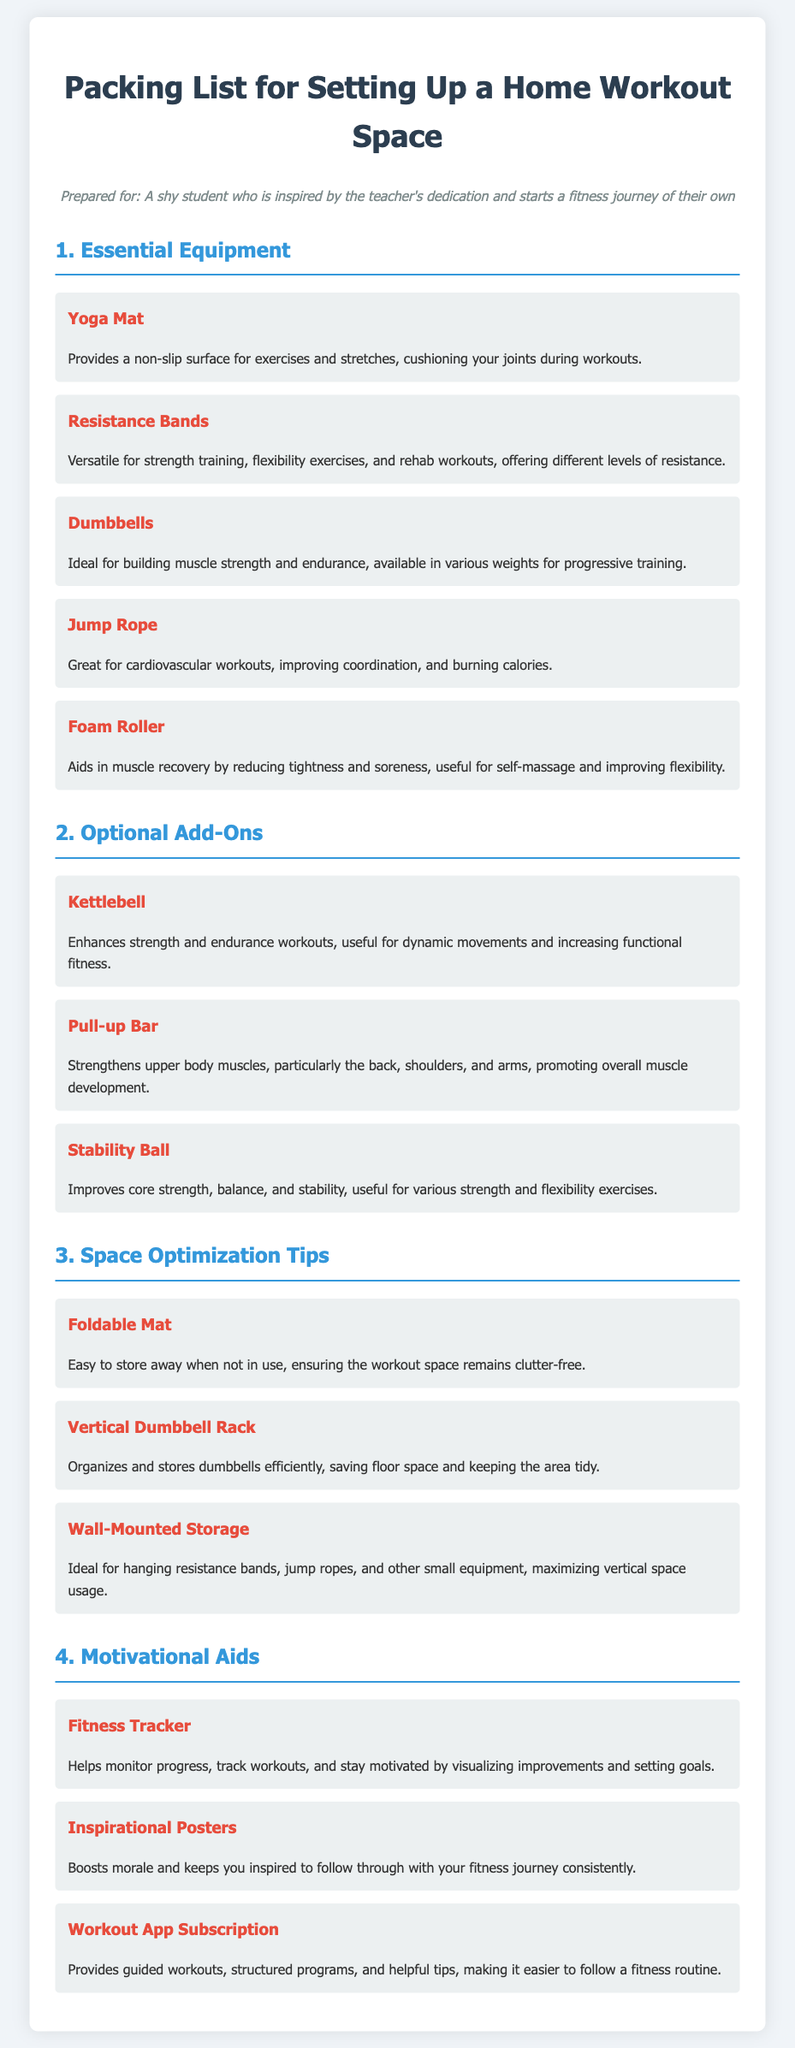what is the first piece of essential equipment listed? The first essential equipment mentioned in the list is the Yoga Mat.
Answer: Yoga Mat how many optional add-ons are mentioned? There are three optional add-ons specified in the document.
Answer: 3 what is one benefit of using resistance bands? Resistance bands are versatile for strength training, flexibility exercises, and rehab workouts.
Answer: Versatile for strength training which item aids in muscle recovery? The Foam Roller aids in muscle recovery by reducing tightness and soreness.
Answer: Foam Roller what type of storage is suggested for maximizing vertical space? Wall-Mounted Storage is recommended for hanging small equipment.
Answer: Wall-Mounted Storage which motivational aid helps monitor progress? The Fitness Tracker helps monitor progress during workouts.
Answer: Fitness Tracker what is the purpose of the inspirational posters? Inspirational Posters are used to boost morale and keep you inspired.
Answer: Boosts morale how can a foldable mat help with space optimization? A Foldable Mat can be easily stored away when not in use.
Answer: Easy to store away 